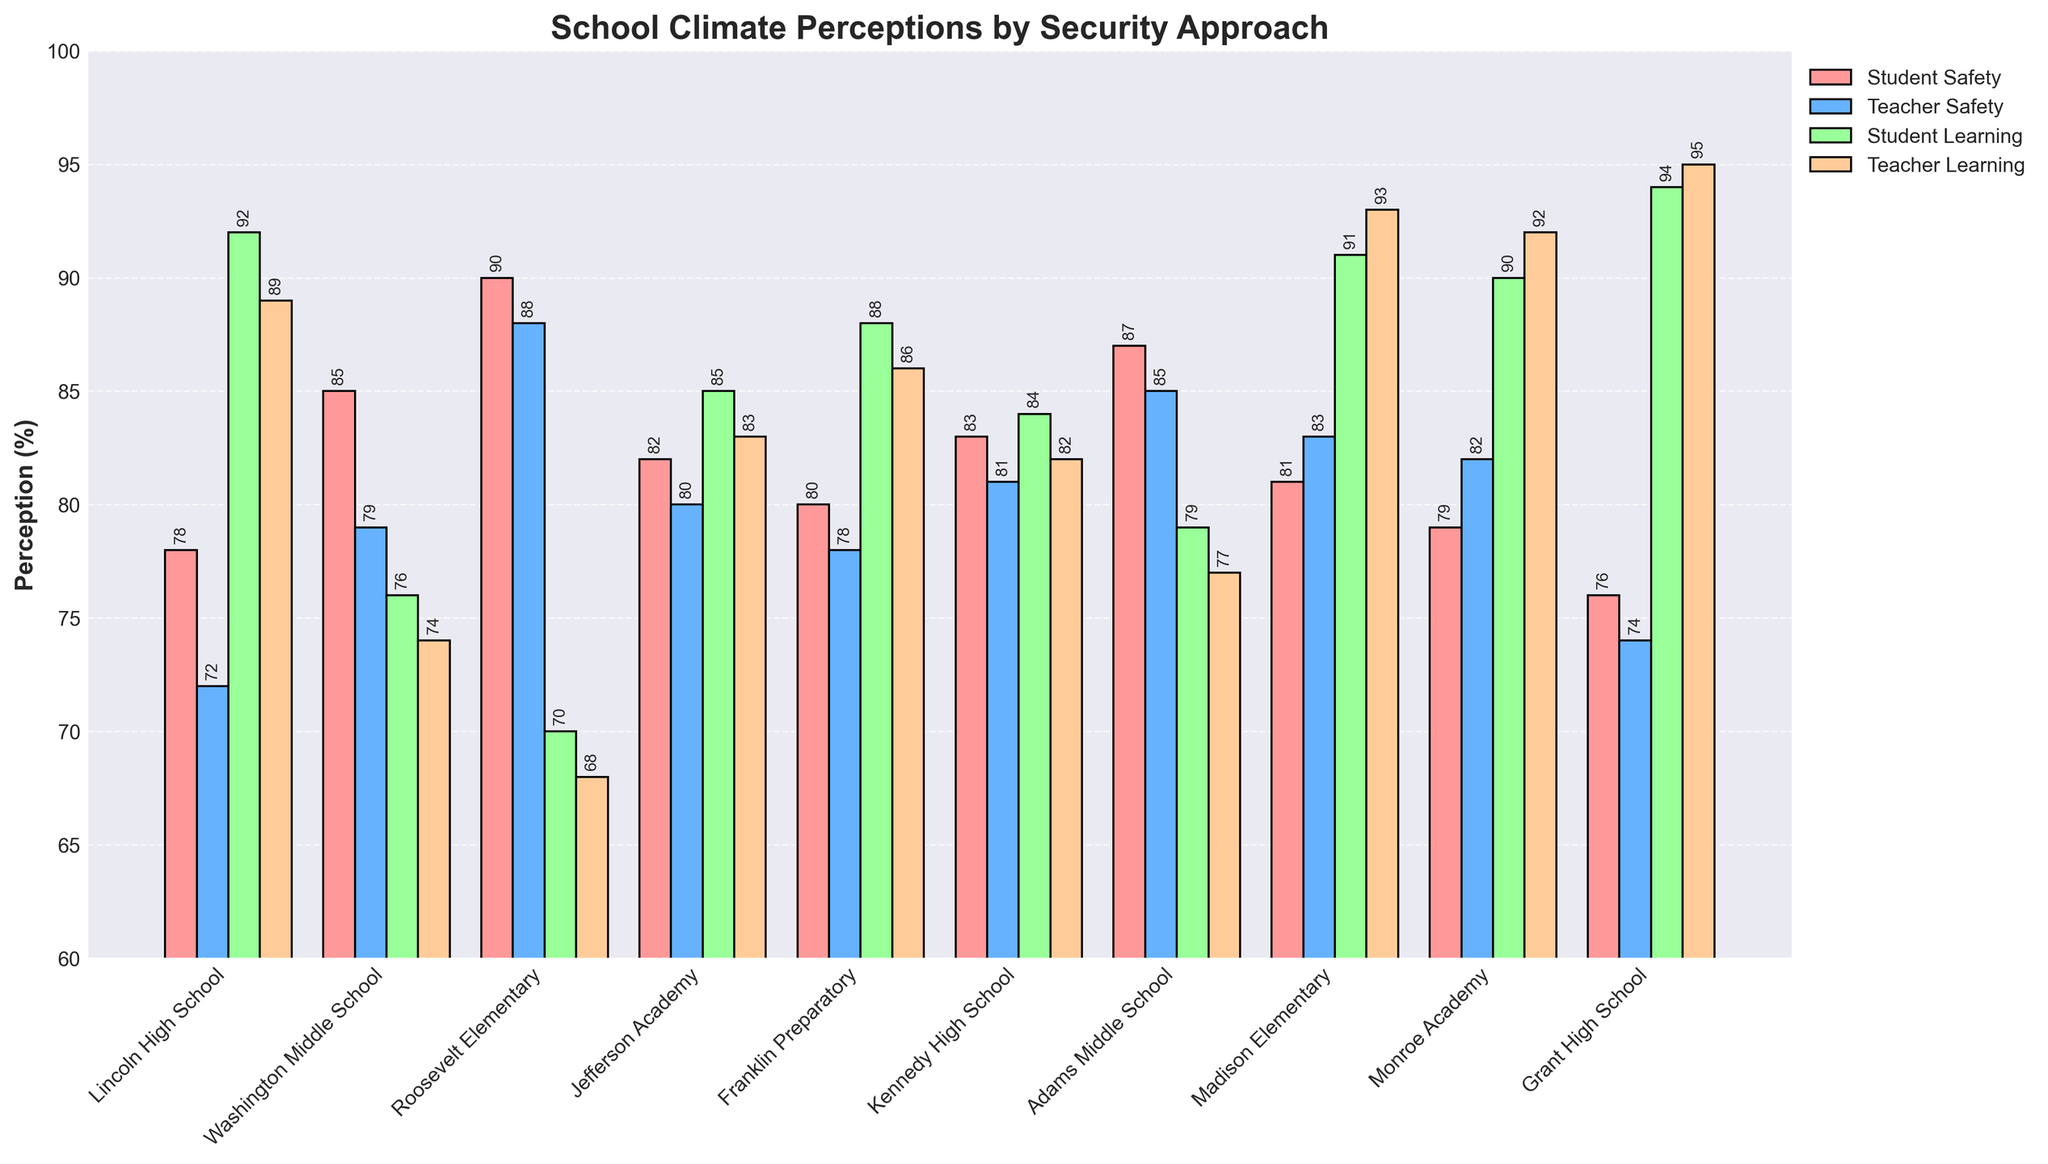What is the difference between student safety perception at Roosevelt Elementary and Kennedy High School? To find the difference, we look at the student safety perception percentages for Roosevelt Elementary and Kennedy High School. Roosevelt Elementary has 90%, and Kennedy High School has 83%. The difference is 90% - 83% = 7%.
Answer: 7% Which school has the highest perception of teacher learning focus? To determine which school has the highest perception of teacher learning focus, we examine the teacher learning focus percentages for all schools. Grant High School has the highest percentage at 95%.
Answer: Grant High School What is the average student perception of safety across all schools? To calculate the average, sum all student safety perception percentages and then divide by the number of schools. The sum is 78 + 85 + 90 + 82 + 80 + 83 + 87 + 81 + 79 + 76 = 821. There are 10 schools, so the average is 821 / 10 = 82.1%.
Answer: 82.1% Which school has a higher teacher learning focus, Jefferson Academy or Franklin Preparatory? By comparing the teacher learning focus percentages, Jefferson Academy has 83% and Franklin Preparatory has 86%. Franklin Preparatory has a higher percentage.
Answer: Franklin Preparatory What is the sum of student safety perception percentages for schools with minimal security and counseling programs? The schools with minimal security and counseling programs are Lincoln High School and Madison Elementary. Their student safety perception percentages are 78% and 81%, respectively. The sum is 78 + 81 = 159%.
Answer: 159% How does the teacher safety perception at Adams Middle School compare to teacher safety perception at Grant High School? Adams Middle School has a teacher safety perception of 85%, and Grant High School has 74%. Adams Middle School has a higher teacher safety perception by 11% (85% - 74%).
Answer: Adams Middle School by 11% What color represents the student learning focus in the bar chart? The student learning focus bars are colored green.
Answer: Green Which schools have both student and teacher safety perceptions above 80%? We need to identify schools where both percentages are above 80%. These are: Roosevelt Elementary (90%, 88%), Jefferson Academy (82%, 80%), Kennedy High School (83%, 81%), Adams Middle School (87%, 85%).
Answer: Roosevelt Elementary, Jefferson Academy, Kennedy High School, Adams Middle School Between Monroe Academy and Grant High School, which has a better perception of student learning focus? Monroe Academy has a student learning focus perception of 90%, and Grant High School has 94%. Grant High School is better.
Answer: Grant High School 